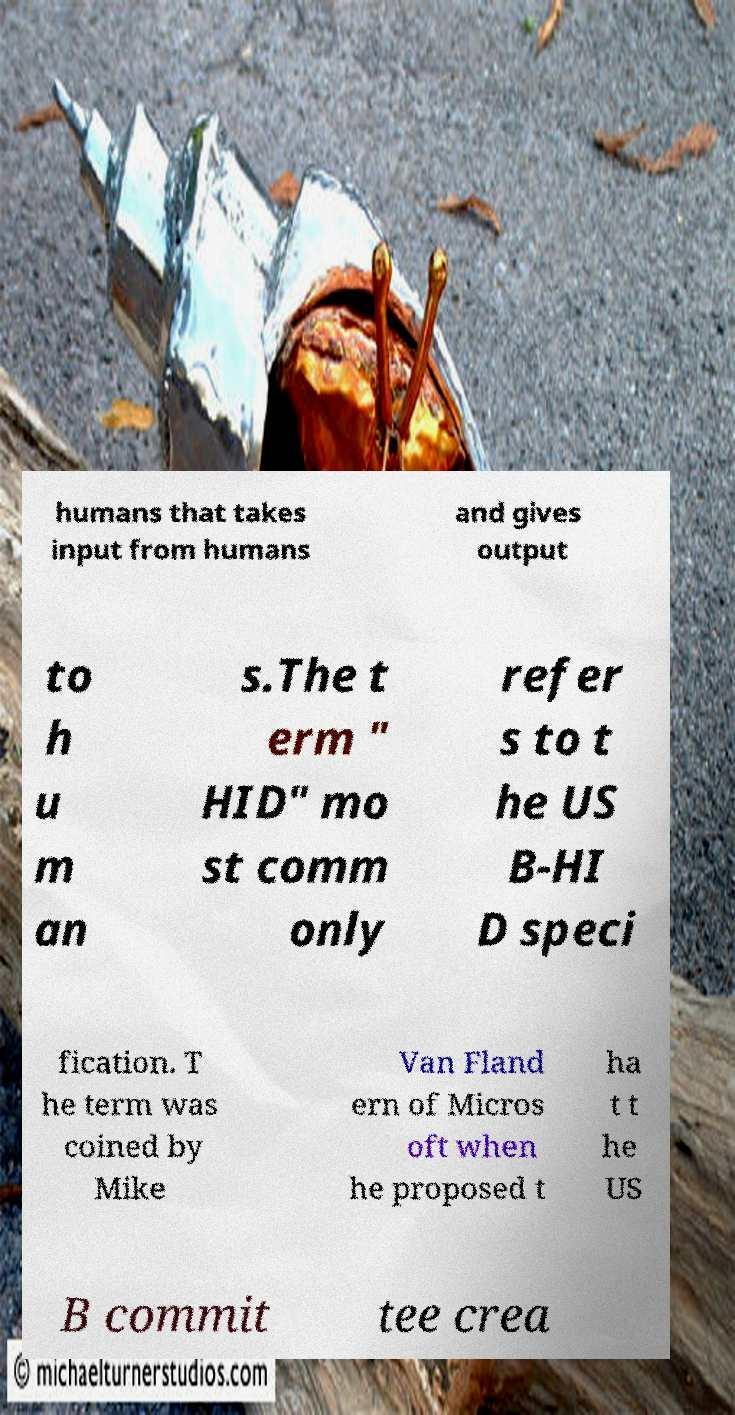For documentation purposes, I need the text within this image transcribed. Could you provide that? humans that takes input from humans and gives output to h u m an s.The t erm " HID" mo st comm only refer s to t he US B-HI D speci fication. T he term was coined by Mike Van Fland ern of Micros oft when he proposed t ha t t he US B commit tee crea 